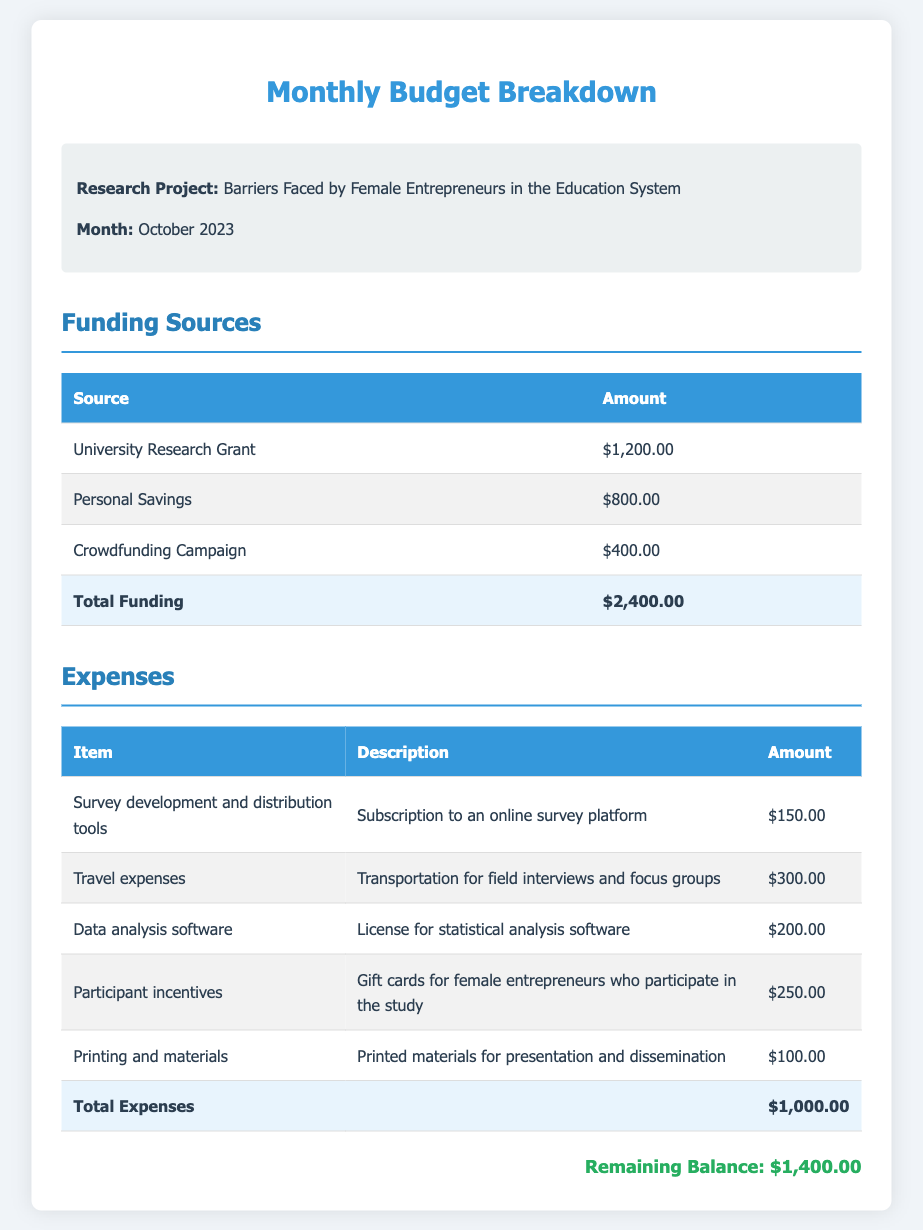what is the total funding? The total funding is the sum of all funding sources listed in the document, which equals $1,200.00 + $800.00 + $400.00 = $2,400.00.
Answer: $2,400.00 what are the participant incentives? Participant incentives refer to the gift cards provided for female entrepreneurs who participate in the study, as mentioned in the expenses section.
Answer: Gift cards how much is allocated for travel expenses? The document specifies the amount for travel expenses incurred during field interviews and focus groups, which is $300.00.
Answer: $300.00 what is the remaining balance after expenses? The remaining balance is calculated as the total funding ($2,400.00) minus total expenses ($1,000.00), resulting in $1,400.00.
Answer: $1,400.00 how much did the survey development and distribution tools cost? The cost for survey development and distribution tools, as indicated in the expenses table, is $150.00.
Answer: $150.00 what is the purpose of the crowdfunding campaign funding? The crowdfunding campaign funding contributes to the total funding for the research project, which is intended to support various expenses related to the study.
Answer: To support expenses how many funding sources are listed? The document lists three different funding sources that contribute to the total funding available for the project.
Answer: Three what is the description for data analysis software? The description for data analysis software explains that it refers to the license for statistical analysis software used in the research project.
Answer: License for statistical analysis software what was spent on printing and materials? The document states the cost spent on printing and materials used for presentation and dissemination is $100.00.
Answer: $100.00 